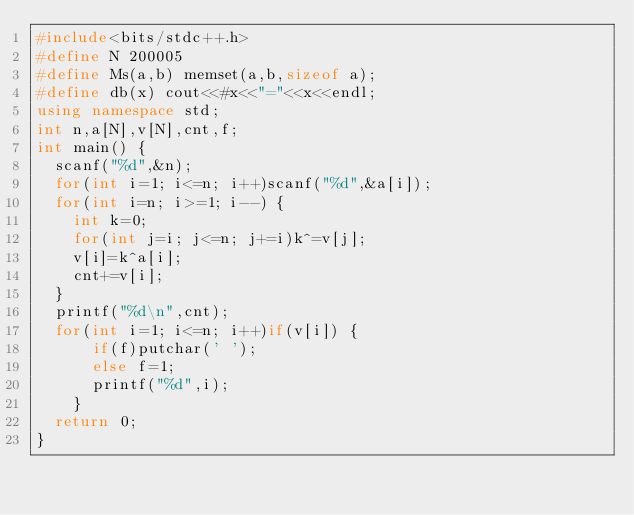Convert code to text. <code><loc_0><loc_0><loc_500><loc_500><_C++_>#include<bits/stdc++.h>
#define N 200005
#define Ms(a,b) memset(a,b,sizeof a);
#define db(x) cout<<#x<<"="<<x<<endl;
using namespace std;
int n,a[N],v[N],cnt,f;
int main() {
	scanf("%d",&n);
	for(int i=1; i<=n; i++)scanf("%d",&a[i]);
	for(int i=n; i>=1; i--) {
		int k=0;
		for(int j=i; j<=n; j+=i)k^=v[j];
		v[i]=k^a[i];
		cnt+=v[i];
	}
	printf("%d\n",cnt);
	for(int i=1; i<=n; i++)if(v[i]) {
			if(f)putchar(' ');
			else f=1;
			printf("%d",i);
		}
	return 0;
}
</code> 